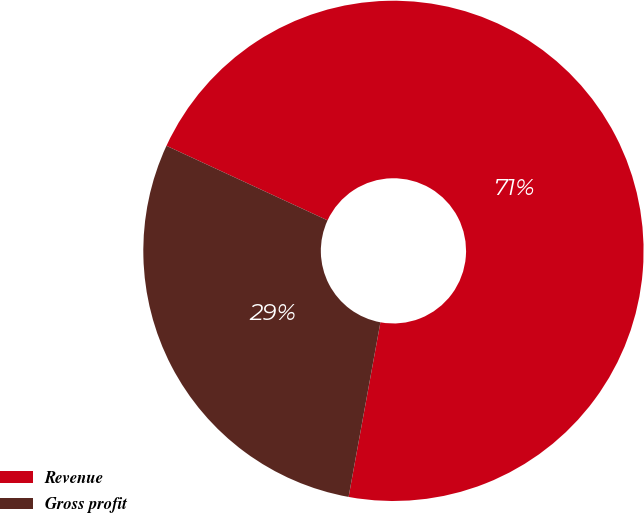<chart> <loc_0><loc_0><loc_500><loc_500><pie_chart><fcel>Revenue<fcel>Gross profit<nl><fcel>70.97%<fcel>29.03%<nl></chart> 